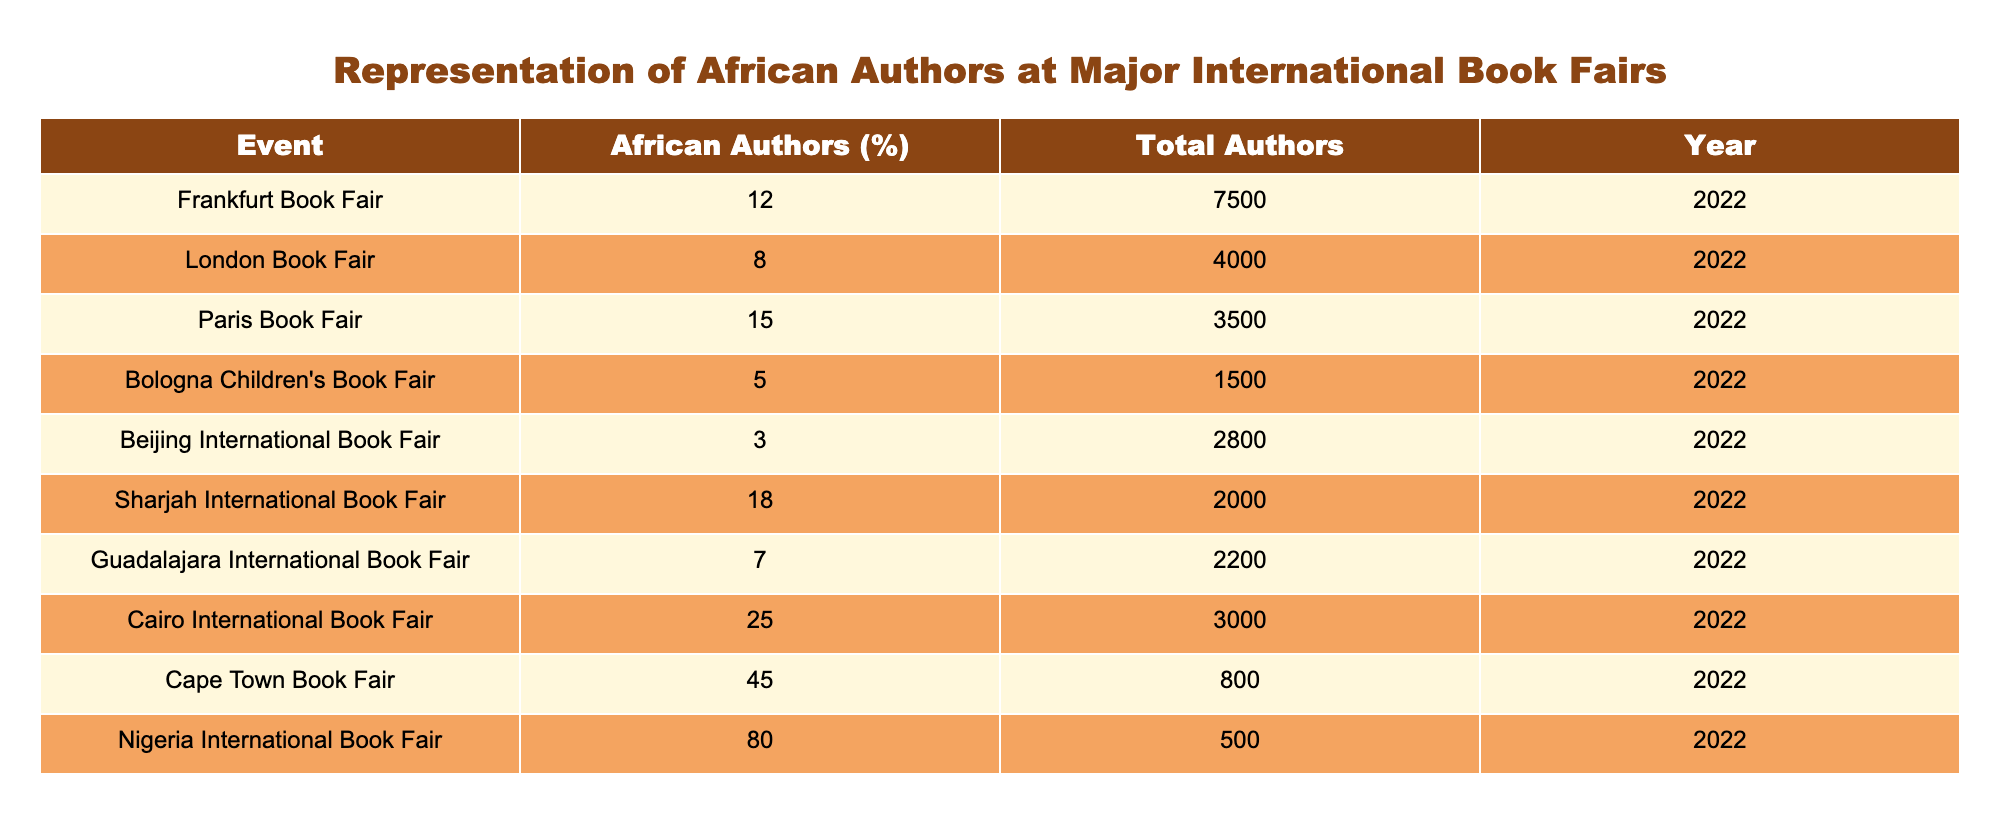What is the percentage of African authors at the Frankfurt Book Fair? According to the table, the percentage of African authors at the Frankfurt Book Fair is listed as 12%.
Answer: 12% Which book fair has the highest percentage of African authors? The table shows that the Nigeria International Book Fair has the highest percentage of African authors at 80%.
Answer: Nigeria International Book Fair What is the total number of authors represented at the Sharjah International Book Fair? From the table, the total number of authors at the Sharjah International Book Fair is 2000.
Answer: 2000 Calculate the average percentage of African authors across all the listed book fairs. First, we sum the percentages: 12 + 8 + 15 + 5 + 3 + 18 + 7 + 25 + 45 + 80 = 218. Then we divide by the number of book fairs, which is 10: 218 / 10 = 21.8%.
Answer: 21.8% Is the representation of African authors at the Paris Book Fair greater than that at the London Book Fair? Comparing the percentages, the Paris Book Fair has 15% while the London Book Fair has 8%. Therefore, the representation at the Paris Book Fair is greater.
Answer: Yes What percentage of authors at the Cairo International Book Fair are African authors compared to the total authors present? The Cairo International Book Fair has 25% of African authors out of a total of 3000 authors, meaning that there is a significant representation of African authors there.
Answer: Yes How many more authors are represented at the London Book Fair compared to the Bologna Children's Book Fair? The London Book Fair has 4000 authors while the Bologna Children's Book Fair has 1500 authors. The difference is 4000 - 1500 = 2500 authors.
Answer: 2500 What is the combined total number of authors represented at the Cape Town and Nigeria International Book Fairs? Adding the totals, the Cape Town Book Fair has 800 authors and the Nigeria International Book Fair has 500 authors. Therefore, the total is 800 + 500 = 1300 authors.
Answer: 1300 Are there more African authors represented at the Beijing International Book Fair than the Bologna Children's Book Fair? The Beijing International Book Fair has 3% and the Bologna Children's Book Fair has 5%. Since 3% is less than 5%, there are fewer African authors at the Beijing fair.
Answer: No 